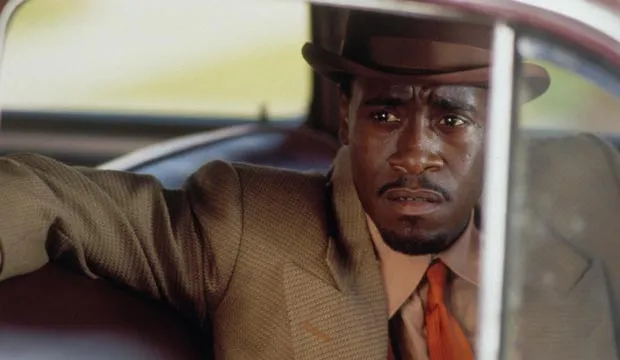What do you think is going on in this snapshot? In the image, a man who appears to be an actor is dressed as a detective in period attire, consisting of a brown suit and a matching fedora. He is seen sitting in the driver's seat of a car with his arm casually resting on the door. His expression is serious and focused, as though he is deeply contemplating something or carefully observing his surroundings outside the car. This evocative moment captures a scene filled with quiet intensity, suggestive of classic detective stories. 